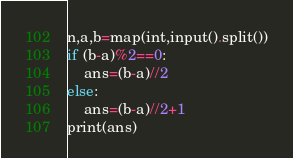<code> <loc_0><loc_0><loc_500><loc_500><_Python_>n,a,b=map(int,input().split())
if (b-a)%2==0:
    ans=(b-a)//2
else:
    ans=(b-a)//2+1
print(ans)</code> 